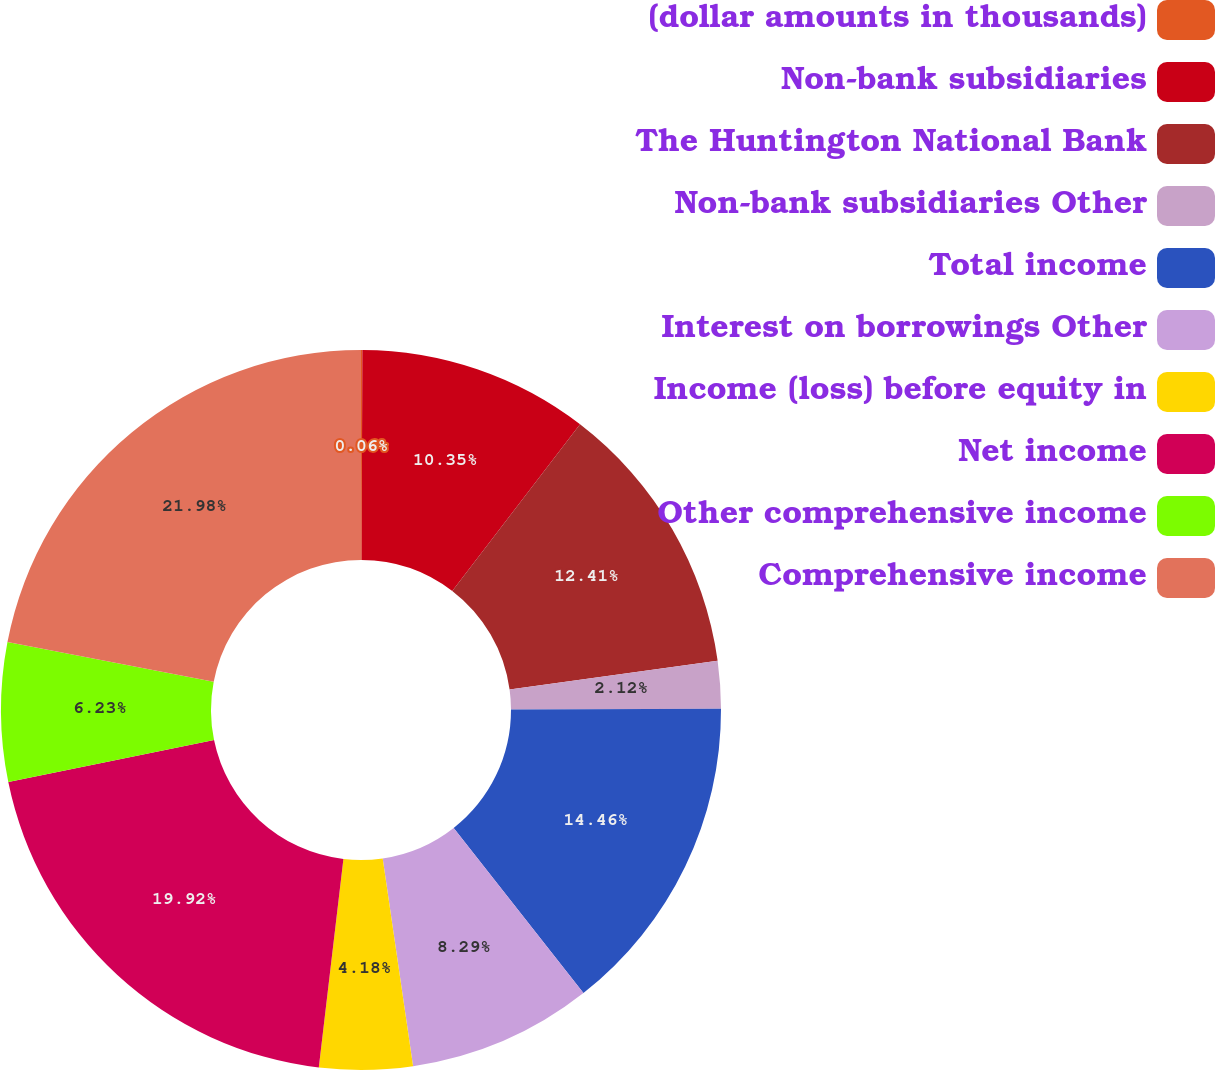Convert chart to OTSL. <chart><loc_0><loc_0><loc_500><loc_500><pie_chart><fcel>(dollar amounts in thousands)<fcel>Non-bank subsidiaries<fcel>The Huntington National Bank<fcel>Non-bank subsidiaries Other<fcel>Total income<fcel>Interest on borrowings Other<fcel>Income (loss) before equity in<fcel>Net income<fcel>Other comprehensive income<fcel>Comprehensive income<nl><fcel>0.06%<fcel>10.35%<fcel>12.41%<fcel>2.12%<fcel>14.46%<fcel>8.29%<fcel>4.18%<fcel>19.92%<fcel>6.23%<fcel>21.98%<nl></chart> 